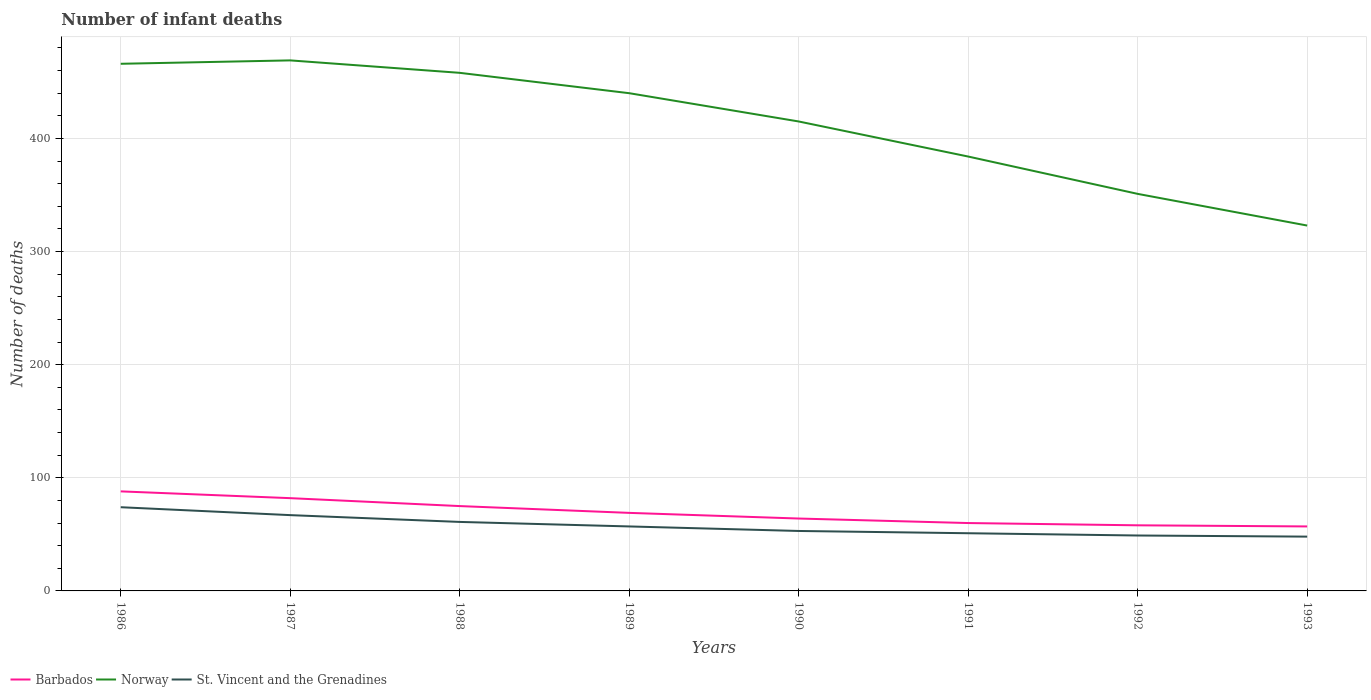Across all years, what is the maximum number of infant deaths in St. Vincent and the Grenadines?
Your answer should be compact. 48. In which year was the number of infant deaths in Norway maximum?
Your response must be concise. 1993. What is the total number of infant deaths in Norway in the graph?
Offer a very short reply. 117. What is the difference between the highest and the second highest number of infant deaths in Barbados?
Your response must be concise. 31. How many lines are there?
Provide a succinct answer. 3. Does the graph contain grids?
Your response must be concise. Yes. What is the title of the graph?
Offer a terse response. Number of infant deaths. What is the label or title of the Y-axis?
Offer a terse response. Number of deaths. What is the Number of deaths in Norway in 1986?
Provide a short and direct response. 466. What is the Number of deaths of Barbados in 1987?
Provide a succinct answer. 82. What is the Number of deaths in Norway in 1987?
Your answer should be compact. 469. What is the Number of deaths of St. Vincent and the Grenadines in 1987?
Make the answer very short. 67. What is the Number of deaths in Norway in 1988?
Give a very brief answer. 458. What is the Number of deaths in Norway in 1989?
Your answer should be compact. 440. What is the Number of deaths in St. Vincent and the Grenadines in 1989?
Give a very brief answer. 57. What is the Number of deaths of Norway in 1990?
Your answer should be very brief. 415. What is the Number of deaths of Norway in 1991?
Your answer should be very brief. 384. What is the Number of deaths in Norway in 1992?
Offer a terse response. 351. What is the Number of deaths of St. Vincent and the Grenadines in 1992?
Your answer should be compact. 49. What is the Number of deaths of Barbados in 1993?
Provide a short and direct response. 57. What is the Number of deaths in Norway in 1993?
Keep it short and to the point. 323. What is the Number of deaths of St. Vincent and the Grenadines in 1993?
Make the answer very short. 48. Across all years, what is the maximum Number of deaths of Norway?
Give a very brief answer. 469. Across all years, what is the maximum Number of deaths in St. Vincent and the Grenadines?
Give a very brief answer. 74. Across all years, what is the minimum Number of deaths in Norway?
Offer a terse response. 323. What is the total Number of deaths of Barbados in the graph?
Give a very brief answer. 553. What is the total Number of deaths in Norway in the graph?
Keep it short and to the point. 3306. What is the total Number of deaths in St. Vincent and the Grenadines in the graph?
Ensure brevity in your answer.  460. What is the difference between the Number of deaths in Norway in 1986 and that in 1987?
Keep it short and to the point. -3. What is the difference between the Number of deaths in Barbados in 1986 and that in 1988?
Your response must be concise. 13. What is the difference between the Number of deaths in Norway in 1986 and that in 1989?
Ensure brevity in your answer.  26. What is the difference between the Number of deaths of Norway in 1986 and that in 1990?
Your response must be concise. 51. What is the difference between the Number of deaths in Norway in 1986 and that in 1991?
Ensure brevity in your answer.  82. What is the difference between the Number of deaths in Barbados in 1986 and that in 1992?
Offer a terse response. 30. What is the difference between the Number of deaths of Norway in 1986 and that in 1992?
Keep it short and to the point. 115. What is the difference between the Number of deaths in Barbados in 1986 and that in 1993?
Provide a short and direct response. 31. What is the difference between the Number of deaths in Norway in 1986 and that in 1993?
Keep it short and to the point. 143. What is the difference between the Number of deaths in St. Vincent and the Grenadines in 1986 and that in 1993?
Make the answer very short. 26. What is the difference between the Number of deaths in Barbados in 1987 and that in 1988?
Make the answer very short. 7. What is the difference between the Number of deaths in Norway in 1987 and that in 1988?
Offer a terse response. 11. What is the difference between the Number of deaths of Norway in 1987 and that in 1989?
Ensure brevity in your answer.  29. What is the difference between the Number of deaths in Norway in 1987 and that in 1991?
Your answer should be compact. 85. What is the difference between the Number of deaths of St. Vincent and the Grenadines in 1987 and that in 1991?
Ensure brevity in your answer.  16. What is the difference between the Number of deaths of Norway in 1987 and that in 1992?
Keep it short and to the point. 118. What is the difference between the Number of deaths of St. Vincent and the Grenadines in 1987 and that in 1992?
Your response must be concise. 18. What is the difference between the Number of deaths in Barbados in 1987 and that in 1993?
Make the answer very short. 25. What is the difference between the Number of deaths in Norway in 1987 and that in 1993?
Offer a terse response. 146. What is the difference between the Number of deaths of Norway in 1988 and that in 1989?
Give a very brief answer. 18. What is the difference between the Number of deaths of St. Vincent and the Grenadines in 1988 and that in 1989?
Offer a very short reply. 4. What is the difference between the Number of deaths in Norway in 1988 and that in 1990?
Your answer should be very brief. 43. What is the difference between the Number of deaths in St. Vincent and the Grenadines in 1988 and that in 1990?
Ensure brevity in your answer.  8. What is the difference between the Number of deaths in Barbados in 1988 and that in 1991?
Give a very brief answer. 15. What is the difference between the Number of deaths of Barbados in 1988 and that in 1992?
Your answer should be very brief. 17. What is the difference between the Number of deaths in Norway in 1988 and that in 1992?
Give a very brief answer. 107. What is the difference between the Number of deaths of St. Vincent and the Grenadines in 1988 and that in 1992?
Give a very brief answer. 12. What is the difference between the Number of deaths in Norway in 1988 and that in 1993?
Give a very brief answer. 135. What is the difference between the Number of deaths of Barbados in 1989 and that in 1990?
Offer a very short reply. 5. What is the difference between the Number of deaths in Norway in 1989 and that in 1990?
Provide a succinct answer. 25. What is the difference between the Number of deaths in St. Vincent and the Grenadines in 1989 and that in 1990?
Make the answer very short. 4. What is the difference between the Number of deaths of Norway in 1989 and that in 1991?
Ensure brevity in your answer.  56. What is the difference between the Number of deaths of Norway in 1989 and that in 1992?
Give a very brief answer. 89. What is the difference between the Number of deaths of St. Vincent and the Grenadines in 1989 and that in 1992?
Keep it short and to the point. 8. What is the difference between the Number of deaths of Barbados in 1989 and that in 1993?
Provide a succinct answer. 12. What is the difference between the Number of deaths of Norway in 1989 and that in 1993?
Provide a succinct answer. 117. What is the difference between the Number of deaths in Norway in 1990 and that in 1991?
Your answer should be very brief. 31. What is the difference between the Number of deaths of Norway in 1990 and that in 1992?
Give a very brief answer. 64. What is the difference between the Number of deaths of Norway in 1990 and that in 1993?
Make the answer very short. 92. What is the difference between the Number of deaths in Barbados in 1991 and that in 1992?
Your response must be concise. 2. What is the difference between the Number of deaths of St. Vincent and the Grenadines in 1991 and that in 1992?
Make the answer very short. 2. What is the difference between the Number of deaths of Barbados in 1991 and that in 1993?
Give a very brief answer. 3. What is the difference between the Number of deaths of Barbados in 1986 and the Number of deaths of Norway in 1987?
Offer a terse response. -381. What is the difference between the Number of deaths of Barbados in 1986 and the Number of deaths of St. Vincent and the Grenadines in 1987?
Provide a succinct answer. 21. What is the difference between the Number of deaths of Norway in 1986 and the Number of deaths of St. Vincent and the Grenadines in 1987?
Offer a terse response. 399. What is the difference between the Number of deaths in Barbados in 1986 and the Number of deaths in Norway in 1988?
Give a very brief answer. -370. What is the difference between the Number of deaths of Barbados in 1986 and the Number of deaths of St. Vincent and the Grenadines in 1988?
Your answer should be very brief. 27. What is the difference between the Number of deaths in Norway in 1986 and the Number of deaths in St. Vincent and the Grenadines in 1988?
Your response must be concise. 405. What is the difference between the Number of deaths in Barbados in 1986 and the Number of deaths in Norway in 1989?
Provide a short and direct response. -352. What is the difference between the Number of deaths in Norway in 1986 and the Number of deaths in St. Vincent and the Grenadines in 1989?
Keep it short and to the point. 409. What is the difference between the Number of deaths in Barbados in 1986 and the Number of deaths in Norway in 1990?
Your answer should be compact. -327. What is the difference between the Number of deaths in Norway in 1986 and the Number of deaths in St. Vincent and the Grenadines in 1990?
Your response must be concise. 413. What is the difference between the Number of deaths of Barbados in 1986 and the Number of deaths of Norway in 1991?
Make the answer very short. -296. What is the difference between the Number of deaths in Norway in 1986 and the Number of deaths in St. Vincent and the Grenadines in 1991?
Provide a short and direct response. 415. What is the difference between the Number of deaths in Barbados in 1986 and the Number of deaths in Norway in 1992?
Make the answer very short. -263. What is the difference between the Number of deaths in Norway in 1986 and the Number of deaths in St. Vincent and the Grenadines in 1992?
Provide a short and direct response. 417. What is the difference between the Number of deaths of Barbados in 1986 and the Number of deaths of Norway in 1993?
Your response must be concise. -235. What is the difference between the Number of deaths in Barbados in 1986 and the Number of deaths in St. Vincent and the Grenadines in 1993?
Offer a very short reply. 40. What is the difference between the Number of deaths in Norway in 1986 and the Number of deaths in St. Vincent and the Grenadines in 1993?
Your answer should be very brief. 418. What is the difference between the Number of deaths in Barbados in 1987 and the Number of deaths in Norway in 1988?
Provide a succinct answer. -376. What is the difference between the Number of deaths of Barbados in 1987 and the Number of deaths of St. Vincent and the Grenadines in 1988?
Offer a terse response. 21. What is the difference between the Number of deaths in Norway in 1987 and the Number of deaths in St. Vincent and the Grenadines in 1988?
Provide a short and direct response. 408. What is the difference between the Number of deaths in Barbados in 1987 and the Number of deaths in Norway in 1989?
Offer a terse response. -358. What is the difference between the Number of deaths in Barbados in 1987 and the Number of deaths in St. Vincent and the Grenadines in 1989?
Provide a short and direct response. 25. What is the difference between the Number of deaths of Norway in 1987 and the Number of deaths of St. Vincent and the Grenadines in 1989?
Keep it short and to the point. 412. What is the difference between the Number of deaths of Barbados in 1987 and the Number of deaths of Norway in 1990?
Provide a succinct answer. -333. What is the difference between the Number of deaths in Norway in 1987 and the Number of deaths in St. Vincent and the Grenadines in 1990?
Ensure brevity in your answer.  416. What is the difference between the Number of deaths of Barbados in 1987 and the Number of deaths of Norway in 1991?
Your answer should be compact. -302. What is the difference between the Number of deaths in Barbados in 1987 and the Number of deaths in St. Vincent and the Grenadines in 1991?
Give a very brief answer. 31. What is the difference between the Number of deaths of Norway in 1987 and the Number of deaths of St. Vincent and the Grenadines in 1991?
Your answer should be very brief. 418. What is the difference between the Number of deaths in Barbados in 1987 and the Number of deaths in Norway in 1992?
Provide a short and direct response. -269. What is the difference between the Number of deaths in Norway in 1987 and the Number of deaths in St. Vincent and the Grenadines in 1992?
Give a very brief answer. 420. What is the difference between the Number of deaths in Barbados in 1987 and the Number of deaths in Norway in 1993?
Keep it short and to the point. -241. What is the difference between the Number of deaths in Norway in 1987 and the Number of deaths in St. Vincent and the Grenadines in 1993?
Your answer should be compact. 421. What is the difference between the Number of deaths in Barbados in 1988 and the Number of deaths in Norway in 1989?
Offer a very short reply. -365. What is the difference between the Number of deaths in Barbados in 1988 and the Number of deaths in St. Vincent and the Grenadines in 1989?
Ensure brevity in your answer.  18. What is the difference between the Number of deaths of Norway in 1988 and the Number of deaths of St. Vincent and the Grenadines in 1989?
Ensure brevity in your answer.  401. What is the difference between the Number of deaths of Barbados in 1988 and the Number of deaths of Norway in 1990?
Your answer should be very brief. -340. What is the difference between the Number of deaths of Norway in 1988 and the Number of deaths of St. Vincent and the Grenadines in 1990?
Provide a short and direct response. 405. What is the difference between the Number of deaths in Barbados in 1988 and the Number of deaths in Norway in 1991?
Make the answer very short. -309. What is the difference between the Number of deaths in Norway in 1988 and the Number of deaths in St. Vincent and the Grenadines in 1991?
Ensure brevity in your answer.  407. What is the difference between the Number of deaths of Barbados in 1988 and the Number of deaths of Norway in 1992?
Offer a very short reply. -276. What is the difference between the Number of deaths of Barbados in 1988 and the Number of deaths of St. Vincent and the Grenadines in 1992?
Your response must be concise. 26. What is the difference between the Number of deaths of Norway in 1988 and the Number of deaths of St. Vincent and the Grenadines in 1992?
Make the answer very short. 409. What is the difference between the Number of deaths in Barbados in 1988 and the Number of deaths in Norway in 1993?
Give a very brief answer. -248. What is the difference between the Number of deaths in Barbados in 1988 and the Number of deaths in St. Vincent and the Grenadines in 1993?
Your response must be concise. 27. What is the difference between the Number of deaths of Norway in 1988 and the Number of deaths of St. Vincent and the Grenadines in 1993?
Provide a succinct answer. 410. What is the difference between the Number of deaths of Barbados in 1989 and the Number of deaths of Norway in 1990?
Give a very brief answer. -346. What is the difference between the Number of deaths of Barbados in 1989 and the Number of deaths of St. Vincent and the Grenadines in 1990?
Your answer should be compact. 16. What is the difference between the Number of deaths in Norway in 1989 and the Number of deaths in St. Vincent and the Grenadines in 1990?
Offer a terse response. 387. What is the difference between the Number of deaths of Barbados in 1989 and the Number of deaths of Norway in 1991?
Provide a short and direct response. -315. What is the difference between the Number of deaths in Norway in 1989 and the Number of deaths in St. Vincent and the Grenadines in 1991?
Provide a succinct answer. 389. What is the difference between the Number of deaths of Barbados in 1989 and the Number of deaths of Norway in 1992?
Offer a very short reply. -282. What is the difference between the Number of deaths in Norway in 1989 and the Number of deaths in St. Vincent and the Grenadines in 1992?
Your answer should be very brief. 391. What is the difference between the Number of deaths in Barbados in 1989 and the Number of deaths in Norway in 1993?
Provide a short and direct response. -254. What is the difference between the Number of deaths of Barbados in 1989 and the Number of deaths of St. Vincent and the Grenadines in 1993?
Offer a terse response. 21. What is the difference between the Number of deaths in Norway in 1989 and the Number of deaths in St. Vincent and the Grenadines in 1993?
Ensure brevity in your answer.  392. What is the difference between the Number of deaths of Barbados in 1990 and the Number of deaths of Norway in 1991?
Give a very brief answer. -320. What is the difference between the Number of deaths of Barbados in 1990 and the Number of deaths of St. Vincent and the Grenadines in 1991?
Your answer should be compact. 13. What is the difference between the Number of deaths of Norway in 1990 and the Number of deaths of St. Vincent and the Grenadines in 1991?
Keep it short and to the point. 364. What is the difference between the Number of deaths in Barbados in 1990 and the Number of deaths in Norway in 1992?
Keep it short and to the point. -287. What is the difference between the Number of deaths in Norway in 1990 and the Number of deaths in St. Vincent and the Grenadines in 1992?
Keep it short and to the point. 366. What is the difference between the Number of deaths of Barbados in 1990 and the Number of deaths of Norway in 1993?
Give a very brief answer. -259. What is the difference between the Number of deaths in Barbados in 1990 and the Number of deaths in St. Vincent and the Grenadines in 1993?
Your answer should be compact. 16. What is the difference between the Number of deaths of Norway in 1990 and the Number of deaths of St. Vincent and the Grenadines in 1993?
Your response must be concise. 367. What is the difference between the Number of deaths in Barbados in 1991 and the Number of deaths in Norway in 1992?
Give a very brief answer. -291. What is the difference between the Number of deaths in Norway in 1991 and the Number of deaths in St. Vincent and the Grenadines in 1992?
Keep it short and to the point. 335. What is the difference between the Number of deaths in Barbados in 1991 and the Number of deaths in Norway in 1993?
Ensure brevity in your answer.  -263. What is the difference between the Number of deaths of Barbados in 1991 and the Number of deaths of St. Vincent and the Grenadines in 1993?
Offer a terse response. 12. What is the difference between the Number of deaths of Norway in 1991 and the Number of deaths of St. Vincent and the Grenadines in 1993?
Keep it short and to the point. 336. What is the difference between the Number of deaths in Barbados in 1992 and the Number of deaths in Norway in 1993?
Your answer should be compact. -265. What is the difference between the Number of deaths of Norway in 1992 and the Number of deaths of St. Vincent and the Grenadines in 1993?
Offer a very short reply. 303. What is the average Number of deaths in Barbados per year?
Keep it short and to the point. 69.12. What is the average Number of deaths of Norway per year?
Make the answer very short. 413.25. What is the average Number of deaths of St. Vincent and the Grenadines per year?
Offer a very short reply. 57.5. In the year 1986, what is the difference between the Number of deaths of Barbados and Number of deaths of Norway?
Offer a terse response. -378. In the year 1986, what is the difference between the Number of deaths of Barbados and Number of deaths of St. Vincent and the Grenadines?
Your answer should be compact. 14. In the year 1986, what is the difference between the Number of deaths of Norway and Number of deaths of St. Vincent and the Grenadines?
Make the answer very short. 392. In the year 1987, what is the difference between the Number of deaths of Barbados and Number of deaths of Norway?
Provide a succinct answer. -387. In the year 1987, what is the difference between the Number of deaths of Norway and Number of deaths of St. Vincent and the Grenadines?
Provide a short and direct response. 402. In the year 1988, what is the difference between the Number of deaths in Barbados and Number of deaths in Norway?
Your answer should be very brief. -383. In the year 1988, what is the difference between the Number of deaths in Norway and Number of deaths in St. Vincent and the Grenadines?
Your answer should be very brief. 397. In the year 1989, what is the difference between the Number of deaths of Barbados and Number of deaths of Norway?
Make the answer very short. -371. In the year 1989, what is the difference between the Number of deaths in Barbados and Number of deaths in St. Vincent and the Grenadines?
Give a very brief answer. 12. In the year 1989, what is the difference between the Number of deaths of Norway and Number of deaths of St. Vincent and the Grenadines?
Provide a short and direct response. 383. In the year 1990, what is the difference between the Number of deaths of Barbados and Number of deaths of Norway?
Keep it short and to the point. -351. In the year 1990, what is the difference between the Number of deaths in Norway and Number of deaths in St. Vincent and the Grenadines?
Offer a terse response. 362. In the year 1991, what is the difference between the Number of deaths in Barbados and Number of deaths in Norway?
Provide a short and direct response. -324. In the year 1991, what is the difference between the Number of deaths in Barbados and Number of deaths in St. Vincent and the Grenadines?
Your answer should be very brief. 9. In the year 1991, what is the difference between the Number of deaths of Norway and Number of deaths of St. Vincent and the Grenadines?
Offer a terse response. 333. In the year 1992, what is the difference between the Number of deaths of Barbados and Number of deaths of Norway?
Make the answer very short. -293. In the year 1992, what is the difference between the Number of deaths of Barbados and Number of deaths of St. Vincent and the Grenadines?
Provide a succinct answer. 9. In the year 1992, what is the difference between the Number of deaths of Norway and Number of deaths of St. Vincent and the Grenadines?
Your response must be concise. 302. In the year 1993, what is the difference between the Number of deaths of Barbados and Number of deaths of Norway?
Offer a terse response. -266. In the year 1993, what is the difference between the Number of deaths in Barbados and Number of deaths in St. Vincent and the Grenadines?
Ensure brevity in your answer.  9. In the year 1993, what is the difference between the Number of deaths in Norway and Number of deaths in St. Vincent and the Grenadines?
Offer a very short reply. 275. What is the ratio of the Number of deaths of Barbados in 1986 to that in 1987?
Give a very brief answer. 1.07. What is the ratio of the Number of deaths of Norway in 1986 to that in 1987?
Keep it short and to the point. 0.99. What is the ratio of the Number of deaths of St. Vincent and the Grenadines in 1986 to that in 1987?
Make the answer very short. 1.1. What is the ratio of the Number of deaths of Barbados in 1986 to that in 1988?
Provide a short and direct response. 1.17. What is the ratio of the Number of deaths in Norway in 1986 to that in 1988?
Offer a very short reply. 1.02. What is the ratio of the Number of deaths in St. Vincent and the Grenadines in 1986 to that in 1988?
Offer a terse response. 1.21. What is the ratio of the Number of deaths of Barbados in 1986 to that in 1989?
Give a very brief answer. 1.28. What is the ratio of the Number of deaths of Norway in 1986 to that in 1989?
Provide a succinct answer. 1.06. What is the ratio of the Number of deaths in St. Vincent and the Grenadines in 1986 to that in 1989?
Offer a terse response. 1.3. What is the ratio of the Number of deaths in Barbados in 1986 to that in 1990?
Your answer should be very brief. 1.38. What is the ratio of the Number of deaths of Norway in 1986 to that in 1990?
Your answer should be very brief. 1.12. What is the ratio of the Number of deaths of St. Vincent and the Grenadines in 1986 to that in 1990?
Ensure brevity in your answer.  1.4. What is the ratio of the Number of deaths in Barbados in 1986 to that in 1991?
Provide a short and direct response. 1.47. What is the ratio of the Number of deaths of Norway in 1986 to that in 1991?
Ensure brevity in your answer.  1.21. What is the ratio of the Number of deaths of St. Vincent and the Grenadines in 1986 to that in 1991?
Make the answer very short. 1.45. What is the ratio of the Number of deaths of Barbados in 1986 to that in 1992?
Offer a terse response. 1.52. What is the ratio of the Number of deaths in Norway in 1986 to that in 1992?
Give a very brief answer. 1.33. What is the ratio of the Number of deaths in St. Vincent and the Grenadines in 1986 to that in 1992?
Your response must be concise. 1.51. What is the ratio of the Number of deaths of Barbados in 1986 to that in 1993?
Your answer should be compact. 1.54. What is the ratio of the Number of deaths of Norway in 1986 to that in 1993?
Your answer should be very brief. 1.44. What is the ratio of the Number of deaths of St. Vincent and the Grenadines in 1986 to that in 1993?
Provide a short and direct response. 1.54. What is the ratio of the Number of deaths of Barbados in 1987 to that in 1988?
Your response must be concise. 1.09. What is the ratio of the Number of deaths of Norway in 1987 to that in 1988?
Your answer should be very brief. 1.02. What is the ratio of the Number of deaths of St. Vincent and the Grenadines in 1987 to that in 1988?
Ensure brevity in your answer.  1.1. What is the ratio of the Number of deaths of Barbados in 1987 to that in 1989?
Offer a very short reply. 1.19. What is the ratio of the Number of deaths of Norway in 1987 to that in 1989?
Ensure brevity in your answer.  1.07. What is the ratio of the Number of deaths in St. Vincent and the Grenadines in 1987 to that in 1989?
Provide a short and direct response. 1.18. What is the ratio of the Number of deaths of Barbados in 1987 to that in 1990?
Your response must be concise. 1.28. What is the ratio of the Number of deaths in Norway in 1987 to that in 1990?
Provide a short and direct response. 1.13. What is the ratio of the Number of deaths of St. Vincent and the Grenadines in 1987 to that in 1990?
Offer a very short reply. 1.26. What is the ratio of the Number of deaths in Barbados in 1987 to that in 1991?
Offer a terse response. 1.37. What is the ratio of the Number of deaths in Norway in 1987 to that in 1991?
Offer a very short reply. 1.22. What is the ratio of the Number of deaths in St. Vincent and the Grenadines in 1987 to that in 1991?
Your answer should be very brief. 1.31. What is the ratio of the Number of deaths of Barbados in 1987 to that in 1992?
Your answer should be compact. 1.41. What is the ratio of the Number of deaths of Norway in 1987 to that in 1992?
Make the answer very short. 1.34. What is the ratio of the Number of deaths of St. Vincent and the Grenadines in 1987 to that in 1992?
Give a very brief answer. 1.37. What is the ratio of the Number of deaths of Barbados in 1987 to that in 1993?
Offer a terse response. 1.44. What is the ratio of the Number of deaths in Norway in 1987 to that in 1993?
Provide a short and direct response. 1.45. What is the ratio of the Number of deaths in St. Vincent and the Grenadines in 1987 to that in 1993?
Offer a terse response. 1.4. What is the ratio of the Number of deaths in Barbados in 1988 to that in 1989?
Make the answer very short. 1.09. What is the ratio of the Number of deaths in Norway in 1988 to that in 1989?
Keep it short and to the point. 1.04. What is the ratio of the Number of deaths in St. Vincent and the Grenadines in 1988 to that in 1989?
Offer a terse response. 1.07. What is the ratio of the Number of deaths of Barbados in 1988 to that in 1990?
Your response must be concise. 1.17. What is the ratio of the Number of deaths of Norway in 1988 to that in 1990?
Give a very brief answer. 1.1. What is the ratio of the Number of deaths in St. Vincent and the Grenadines in 1988 to that in 1990?
Your response must be concise. 1.15. What is the ratio of the Number of deaths in Norway in 1988 to that in 1991?
Keep it short and to the point. 1.19. What is the ratio of the Number of deaths of St. Vincent and the Grenadines in 1988 to that in 1991?
Ensure brevity in your answer.  1.2. What is the ratio of the Number of deaths in Barbados in 1988 to that in 1992?
Give a very brief answer. 1.29. What is the ratio of the Number of deaths of Norway in 1988 to that in 1992?
Your answer should be compact. 1.3. What is the ratio of the Number of deaths in St. Vincent and the Grenadines in 1988 to that in 1992?
Offer a very short reply. 1.24. What is the ratio of the Number of deaths of Barbados in 1988 to that in 1993?
Provide a short and direct response. 1.32. What is the ratio of the Number of deaths of Norway in 1988 to that in 1993?
Ensure brevity in your answer.  1.42. What is the ratio of the Number of deaths in St. Vincent and the Grenadines in 1988 to that in 1993?
Ensure brevity in your answer.  1.27. What is the ratio of the Number of deaths in Barbados in 1989 to that in 1990?
Provide a short and direct response. 1.08. What is the ratio of the Number of deaths in Norway in 1989 to that in 1990?
Provide a succinct answer. 1.06. What is the ratio of the Number of deaths of St. Vincent and the Grenadines in 1989 to that in 1990?
Make the answer very short. 1.08. What is the ratio of the Number of deaths in Barbados in 1989 to that in 1991?
Ensure brevity in your answer.  1.15. What is the ratio of the Number of deaths in Norway in 1989 to that in 1991?
Your answer should be compact. 1.15. What is the ratio of the Number of deaths of St. Vincent and the Grenadines in 1989 to that in 1991?
Your answer should be very brief. 1.12. What is the ratio of the Number of deaths in Barbados in 1989 to that in 1992?
Give a very brief answer. 1.19. What is the ratio of the Number of deaths in Norway in 1989 to that in 1992?
Your answer should be compact. 1.25. What is the ratio of the Number of deaths of St. Vincent and the Grenadines in 1989 to that in 1992?
Your answer should be compact. 1.16. What is the ratio of the Number of deaths of Barbados in 1989 to that in 1993?
Your answer should be very brief. 1.21. What is the ratio of the Number of deaths in Norway in 1989 to that in 1993?
Your answer should be compact. 1.36. What is the ratio of the Number of deaths of St. Vincent and the Grenadines in 1989 to that in 1993?
Offer a very short reply. 1.19. What is the ratio of the Number of deaths of Barbados in 1990 to that in 1991?
Ensure brevity in your answer.  1.07. What is the ratio of the Number of deaths of Norway in 1990 to that in 1991?
Make the answer very short. 1.08. What is the ratio of the Number of deaths in St. Vincent and the Grenadines in 1990 to that in 1991?
Make the answer very short. 1.04. What is the ratio of the Number of deaths in Barbados in 1990 to that in 1992?
Make the answer very short. 1.1. What is the ratio of the Number of deaths of Norway in 1990 to that in 1992?
Provide a succinct answer. 1.18. What is the ratio of the Number of deaths of St. Vincent and the Grenadines in 1990 to that in 1992?
Keep it short and to the point. 1.08. What is the ratio of the Number of deaths of Barbados in 1990 to that in 1993?
Your answer should be compact. 1.12. What is the ratio of the Number of deaths of Norway in 1990 to that in 1993?
Provide a short and direct response. 1.28. What is the ratio of the Number of deaths in St. Vincent and the Grenadines in 1990 to that in 1993?
Your response must be concise. 1.1. What is the ratio of the Number of deaths in Barbados in 1991 to that in 1992?
Your response must be concise. 1.03. What is the ratio of the Number of deaths in Norway in 1991 to that in 1992?
Your response must be concise. 1.09. What is the ratio of the Number of deaths of St. Vincent and the Grenadines in 1991 to that in 1992?
Your response must be concise. 1.04. What is the ratio of the Number of deaths of Barbados in 1991 to that in 1993?
Provide a short and direct response. 1.05. What is the ratio of the Number of deaths of Norway in 1991 to that in 1993?
Your answer should be compact. 1.19. What is the ratio of the Number of deaths of Barbados in 1992 to that in 1993?
Provide a succinct answer. 1.02. What is the ratio of the Number of deaths in Norway in 1992 to that in 1993?
Provide a short and direct response. 1.09. What is the ratio of the Number of deaths in St. Vincent and the Grenadines in 1992 to that in 1993?
Keep it short and to the point. 1.02. What is the difference between the highest and the second highest Number of deaths in Norway?
Your response must be concise. 3. What is the difference between the highest and the lowest Number of deaths of Norway?
Your answer should be compact. 146. What is the difference between the highest and the lowest Number of deaths in St. Vincent and the Grenadines?
Give a very brief answer. 26. 